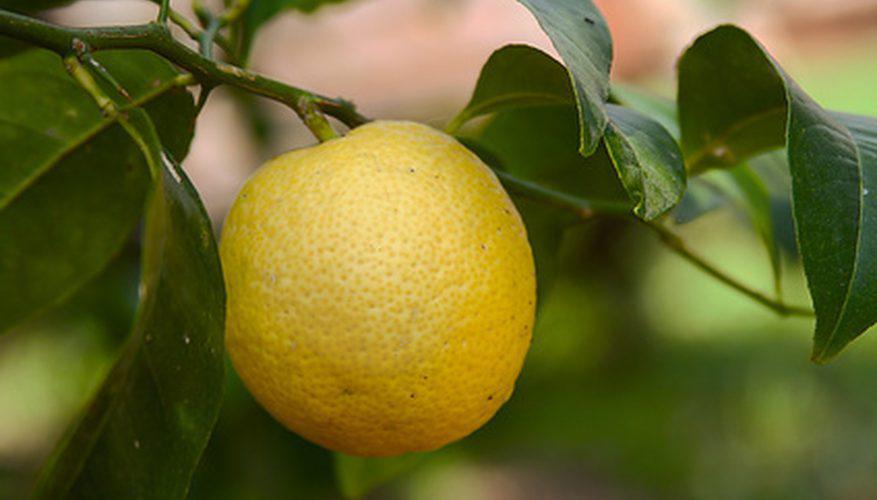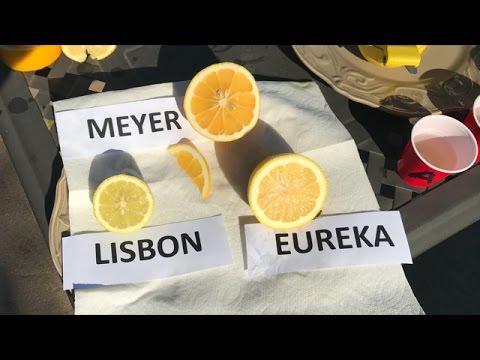The first image is the image on the left, the second image is the image on the right. For the images displayed, is the sentence "All of the fruit is whole and is not on a tree." factually correct? Answer yes or no. No. The first image is the image on the left, the second image is the image on the right. Given the left and right images, does the statement "None of the lemons in the images have been sliced open." hold true? Answer yes or no. No. 